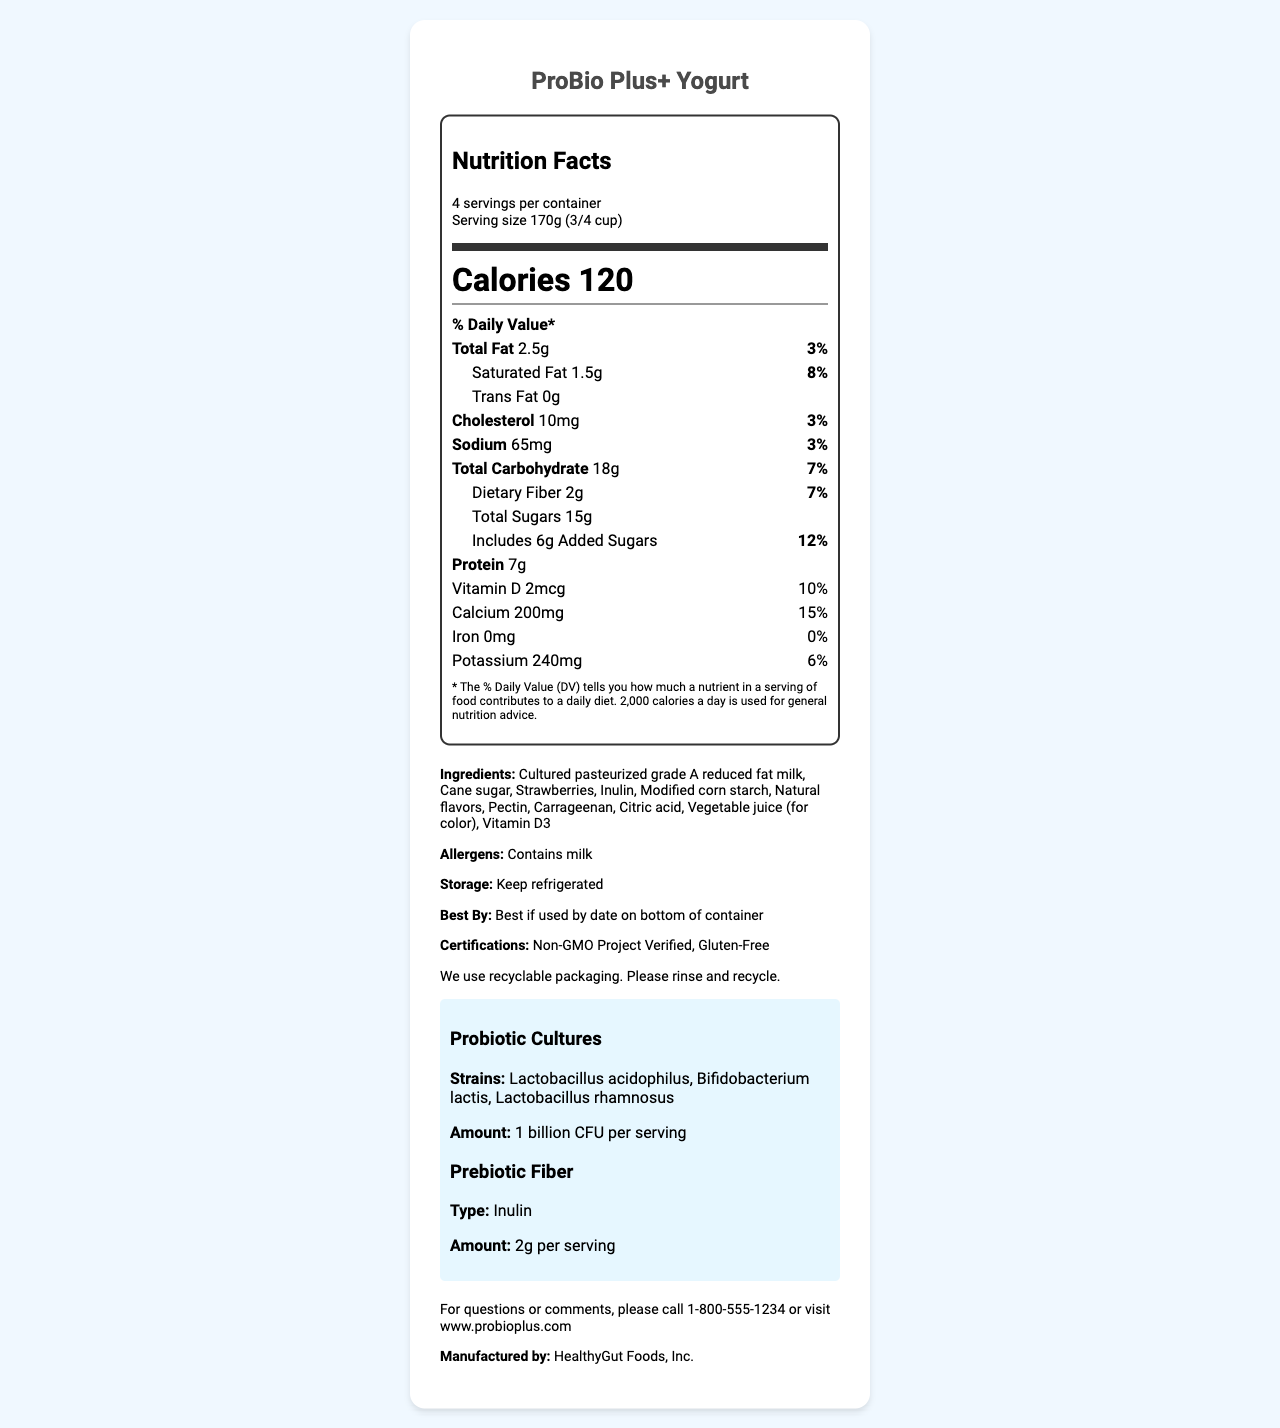what is the serving size of ProBio Plus+ Yogurt? The serving size is stated in the Nutrition Facts label under "Serving size."
Answer: 170g (3/4 cup) how many servings are there per container? The label indicates "4 servings per container."
Answer: 4 how many calories are in a single serving of this yogurt? The number of calories per serving is listed as "Calories 120."
Answer: 120 what is the total fat content per serving? The total fat content is shown as "Total Fat 2.5g."
Answer: 2.5g how much protein does each serving contain? The protein content per serving is listed as "Protein 7g."
Answer: 7g which probiotic strains are included in ProBio Plus+ Yogurt? The probiotic strains are specified under "Probiotic Cultures" in the document.
Answer: Lactobacillus acidophilus, Bifidobacterium lactis, Lactobacillus rhamnosus what is the amount of prebiotic fiber per serving and its type? The document states "Prebiotic Fiber" as "2g per serving" and the type is "Inulin."
Answer: 2g, Inulin how much added sugar is present in the yogurt? "Added Sugars" is listed as 6g in the label.
Answer: 6g how much calcium is in one serving of ProBio Plus+ Yogurt? The calcium content is listed in the nutrient details as "Calcium 200mg."
Answer: 200mg is this product gluten-free? The certifications section lists "Gluten-Free."
Answer: Yes how much potassium does each serving provide? A. 100mg B. 150mg C. 240mg D. 300mg The potassium content per serving is "240mg."
Answer: C what is the daily value percentage of saturated fat per serving? A. 3% B. 5% C. 8% D. 10% The daily value percentage of saturated fat is listed as "8%."
Answer: C does this yogurt contain any trans fat? The label indicates "Trans Fat 0g."
Answer: No who is the manufacturer of ProBio Plus+ Yogurt and how can they be contacted? This information is listed at the bottom of the document in the additional information section.
Answer: HealthyGut Foods, Inc., For questions or comments, please call 1-800-555-1234 or visit www.probioplus.com describe the main idea of the document. The document details the comprehensive nutritional data and additional product attributes for ProBio Plus+ Yogurt to help consumers make informed decisions.
Answer: The document is a detailed Nutrition Facts Label for ProBio Plus+ Yogurt, which provides nutritional information, ingredients, probiotics and prebiotic content, allergen information, storage instructions, expiration date details, manufacturer contact information, and certifications. is the information about the vitamin content of the yogurt provided? The label includes details on the vitamin D content with an amount of "2mcg" and a daily value percentage of "10%."
Answer: Yes can you determine the specific flavor of ProBio Plus+ Yogurt from this document? The document lists strawberries in the ingredients but does not explicitly state the flavor. Other natural flavors are mentioned but not specified.
Answer: Not enough information 